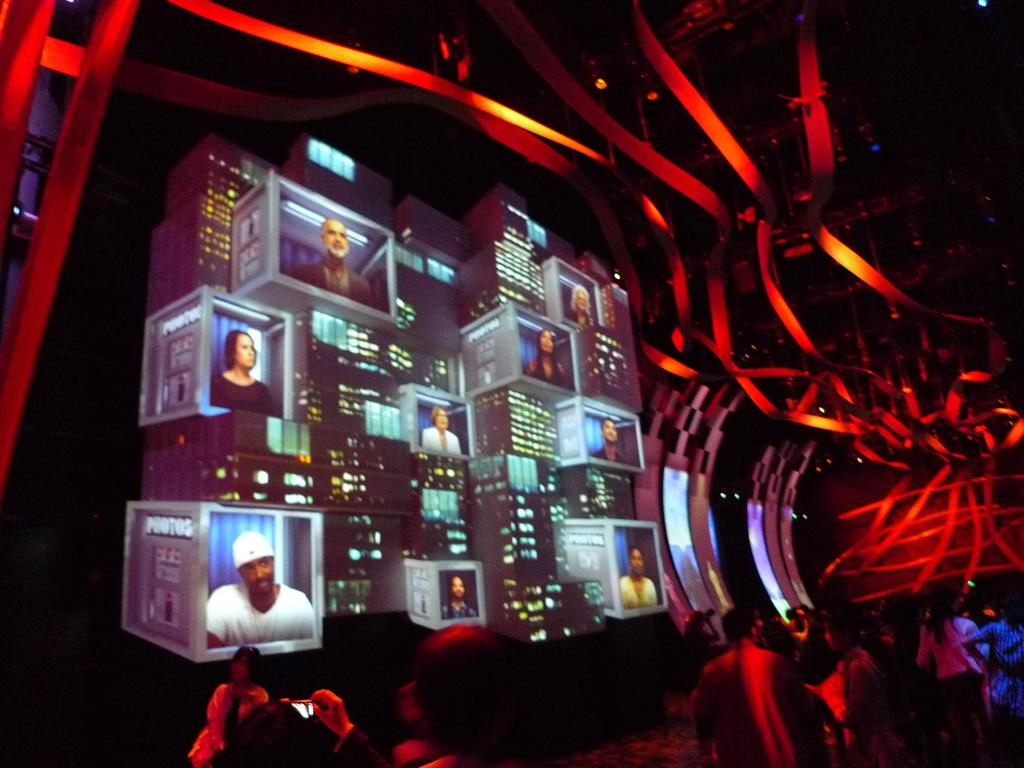What is happening at the bottom of the image? There are many people at the bottom of the image. What can be seen on the screens in the image? There are screens with images of different people. What color are the lights in the image? There are red color lights in the image. What type of powder is being used by the people in the image? There is no mention of powder in the image, so it cannot be determined if any powder is being used. Can you see any mist in the image? There is no mention of mist in the image, so it cannot be determined if any mist is present. 